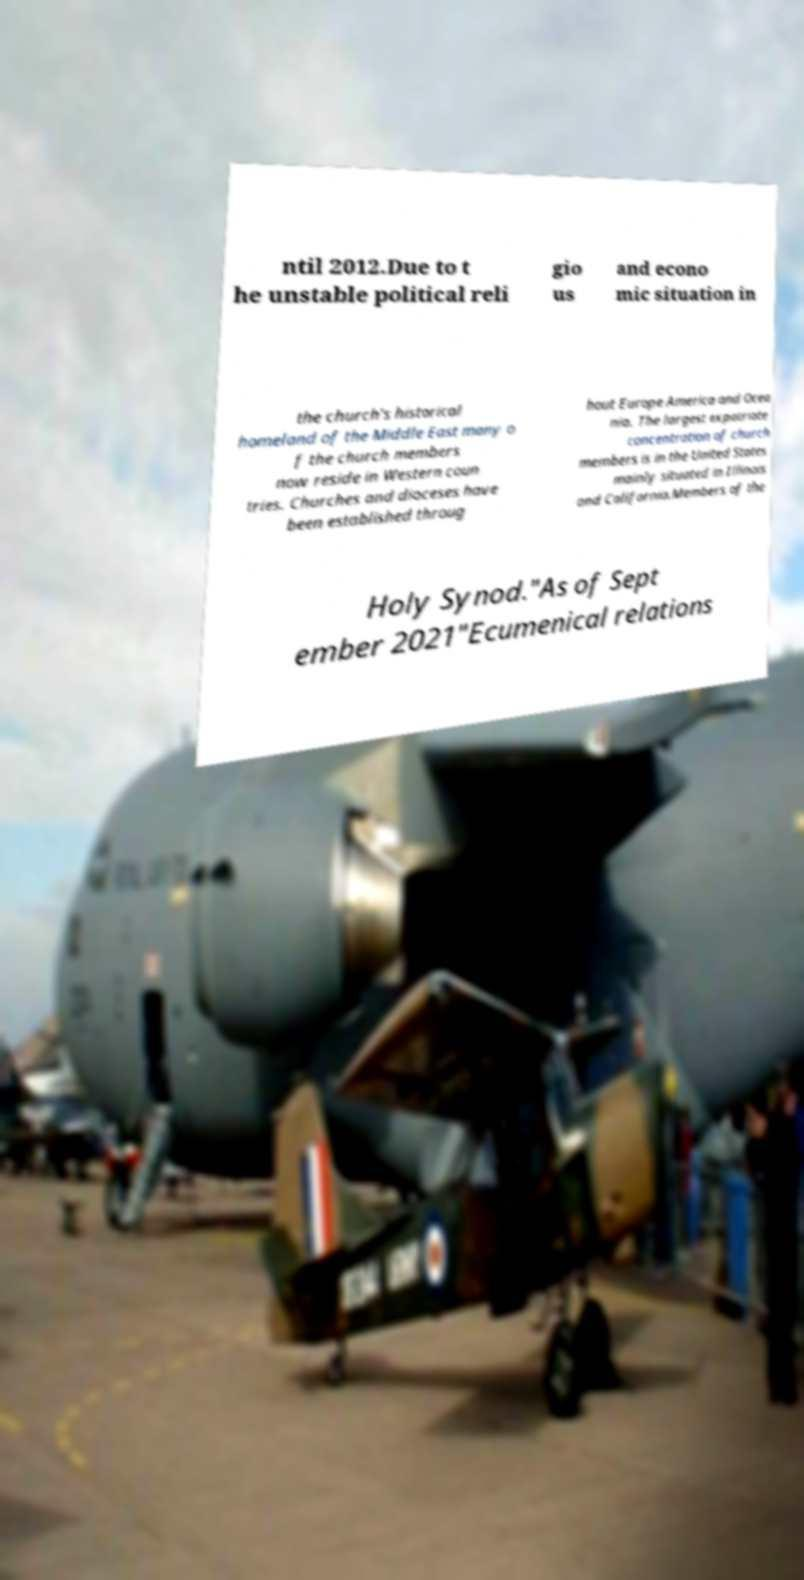Can you accurately transcribe the text from the provided image for me? ntil 2012.Due to t he unstable political reli gio us and econo mic situation in the church's historical homeland of the Middle East many o f the church members now reside in Western coun tries. Churches and dioceses have been established throug hout Europe America and Ocea nia. The largest expatriate concentration of church members is in the United States mainly situated in Illinois and California.Members of the Holy Synod."As of Sept ember 2021"Ecumenical relations 